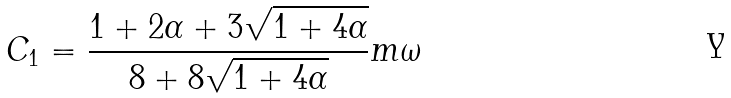<formula> <loc_0><loc_0><loc_500><loc_500>C _ { 1 } = \frac { 1 + 2 \alpha + 3 \sqrt { 1 + 4 \alpha } } { 8 + 8 \sqrt { 1 + 4 \alpha } } m \omega</formula> 